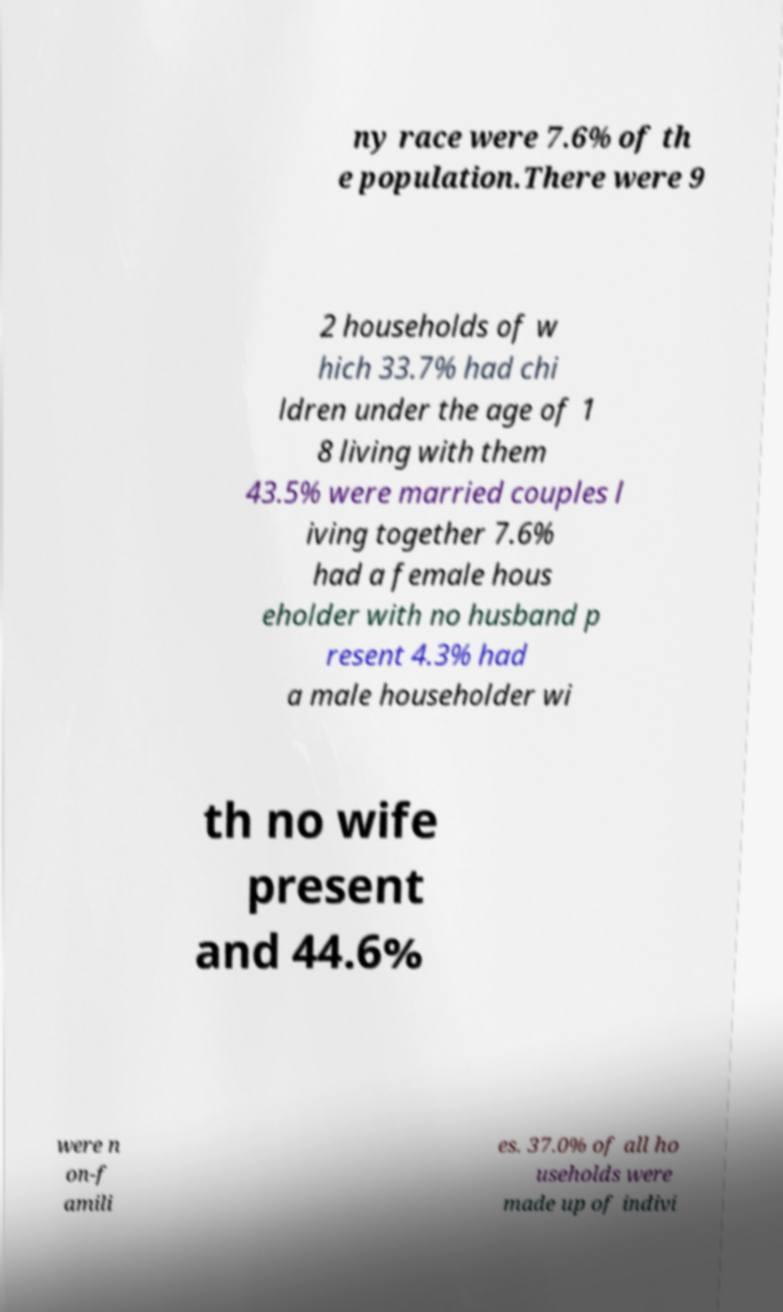There's text embedded in this image that I need extracted. Can you transcribe it verbatim? ny race were 7.6% of th e population.There were 9 2 households of w hich 33.7% had chi ldren under the age of 1 8 living with them 43.5% were married couples l iving together 7.6% had a female hous eholder with no husband p resent 4.3% had a male householder wi th no wife present and 44.6% were n on-f amili es. 37.0% of all ho useholds were made up of indivi 